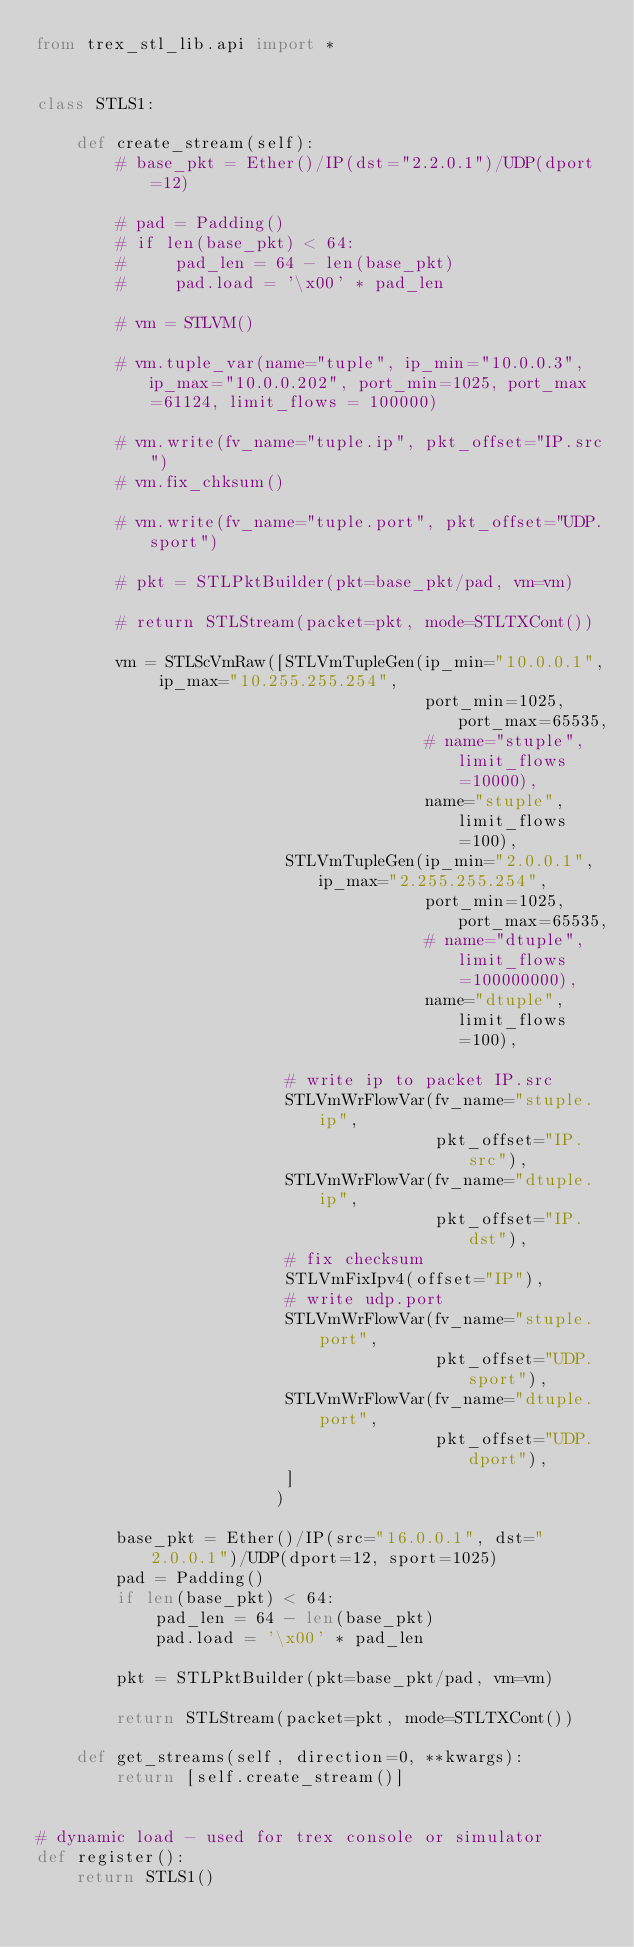<code> <loc_0><loc_0><loc_500><loc_500><_Python_>from trex_stl_lib.api import *


class STLS1:

    def create_stream(self):
        # base_pkt = Ether()/IP(dst="2.2.0.1")/UDP(dport=12)

        # pad = Padding()
        # if len(base_pkt) < 64:
        #     pad_len = 64 - len(base_pkt)
        #     pad.load = '\x00' * pad_len

        # vm = STLVM()

        # vm.tuple_var(name="tuple", ip_min="10.0.0.3", ip_max="10.0.0.202", port_min=1025, port_max=61124, limit_flows = 100000)

        # vm.write(fv_name="tuple.ip", pkt_offset="IP.src")
        # vm.fix_chksum()

        # vm.write(fv_name="tuple.port", pkt_offset="UDP.sport")

        # pkt = STLPktBuilder(pkt=base_pkt/pad, vm=vm)

        # return STLStream(packet=pkt, mode=STLTXCont())

        vm = STLScVmRaw([STLVmTupleGen(ip_min="10.0.0.1", ip_max="10.255.255.254",
                                       port_min=1025, port_max=65535,
                                       # name="stuple", limit_flows=10000),
                                       name="stuple", limit_flows=100),
                         STLVmTupleGen(ip_min="2.0.0.1", ip_max="2.255.255.254",
                                       port_min=1025, port_max=65535,
                                       # name="dtuple", limit_flows=100000000),
                                       name="dtuple", limit_flows=100),

                         # write ip to packet IP.src
                         STLVmWrFlowVar(fv_name="stuple.ip",
                                        pkt_offset="IP.src"),
                         STLVmWrFlowVar(fv_name="dtuple.ip",
                                        pkt_offset="IP.dst"),
                         # fix checksum
                         STLVmFixIpv4(offset="IP"),
                         # write udp.port
                         STLVmWrFlowVar(fv_name="stuple.port",
                                        pkt_offset="UDP.sport"),
                         STLVmWrFlowVar(fv_name="dtuple.port",
                                        pkt_offset="UDP.dport"),
                         ]
                        )

        base_pkt = Ether()/IP(src="16.0.0.1", dst="2.0.0.1")/UDP(dport=12, sport=1025)
        pad = Padding()
        if len(base_pkt) < 64:
            pad_len = 64 - len(base_pkt)
            pad.load = '\x00' * pad_len

        pkt = STLPktBuilder(pkt=base_pkt/pad, vm=vm)

        return STLStream(packet=pkt, mode=STLTXCont())

    def get_streams(self, direction=0, **kwargs):
        return [self.create_stream()]


# dynamic load - used for trex console or simulator
def register():
    return STLS1()
</code> 